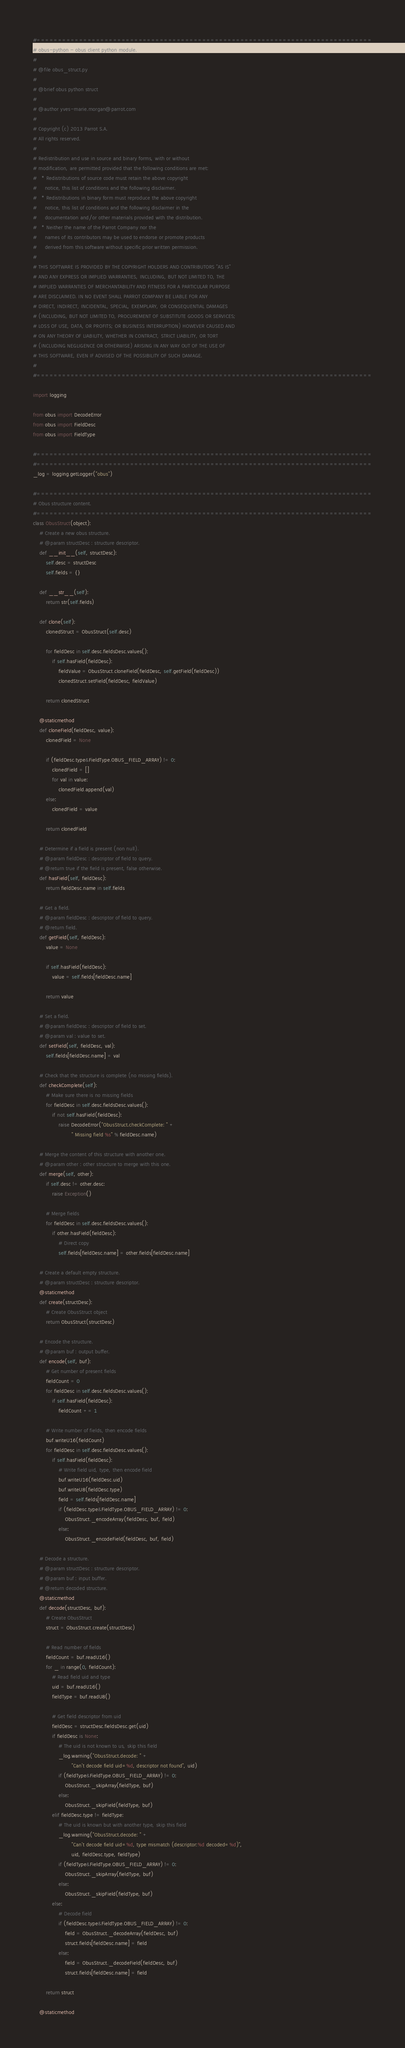Convert code to text. <code><loc_0><loc_0><loc_500><loc_500><_Python_>#===============================================================================
# obus-python - obus client python module.
#
# @file obus_struct.py
#
# @brief obus python struct
#
# @author yves-marie.morgan@parrot.com
#
# Copyright (c) 2013 Parrot S.A.
# All rights reserved.
#
# Redistribution and use in source and binary forms, with or without
# modification, are permitted provided that the following conditions are met:
#   * Redistributions of source code must retain the above copyright
#     notice, this list of conditions and the following disclaimer.
#   * Redistributions in binary form must reproduce the above copyright
#     notice, this list of conditions and the following disclaimer in the
#     documentation and/or other materials provided with the distribution.
#   * Neither the name of the Parrot Company nor the
#     names of its contributors may be used to endorse or promote products
#     derived from this software without specific prior written permission.
#
# THIS SOFTWARE IS PROVIDED BY THE COPYRIGHT HOLDERS AND CONTRIBUTORS "AS IS"
# AND ANY EXPRESS OR IMPLIED WARRANTIES, INCLUDING, BUT NOT LIMITED TO, THE
# IMPLIED WARRANTIES OF MERCHANTABILITY AND FITNESS FOR A PARTICULAR PURPOSE
# ARE DISCLAIMED. IN NO EVENT SHALL PARROT COMPANY BE LIABLE FOR ANY
# DIRECT, INDIRECT, INCIDENTAL, SPECIAL, EXEMPLARY, OR CONSEQUENTIAL DAMAGES
# (INCLUDING, BUT NOT LIMITED TO, PROCUREMENT OF SUBSTITUTE GOODS OR SERVICES;
# LOSS OF USE, DATA, OR PROFITS; OR BUSINESS INTERRUPTION) HOWEVER CAUSED AND
# ON ANY THEORY OF LIABILITY, WHETHER IN CONTRACT, STRICT LIABILITY, OR TORT
# (INCLUDING NEGLIGENCE OR OTHERWISE) ARISING IN ANY WAY OUT OF THE USE OF
# THIS SOFTWARE, EVEN IF ADVISED OF THE POSSIBILITY OF SUCH DAMAGE.
#
#===============================================================================

import logging

from obus import DecodeError
from obus import FieldDesc
from obus import FieldType

#===============================================================================
#===============================================================================
_log = logging.getLogger("obus")

#===============================================================================
# Obus structure content.
#===============================================================================
class ObusStruct(object):
	# Create a new obus structure.
	# @param structDesc : structure descriptor.
	def __init__(self, structDesc):
		self.desc = structDesc
		self.fields = {}

	def __str__(self):
		return str(self.fields)

	def clone(self):
		clonedStruct = ObusStruct(self.desc)

		for fieldDesc in self.desc.fieldsDesc.values():
			if self.hasField(fieldDesc):
				fieldValue = ObusStruct.cloneField(fieldDesc, self.getField(fieldDesc))
				clonedStruct.setField(fieldDesc, fieldValue)

		return clonedStruct

	@staticmethod
	def cloneField(fieldDesc, value):
		clonedField = None

		if (fieldDesc.type&FieldType.OBUS_FIELD_ARRAY) != 0:
			clonedField = []
			for val in value:
				clonedField.append(val)
		else:
			clonedField = value

		return clonedField

	# Determine if a field is present (non null).
	# @param fieldDesc : descriptor of field to query.
	# @return true if the field is present, false otherwise.
	def hasField(self, fieldDesc):
		return fieldDesc.name in self.fields

	# Get a field.
	# @param fieldDesc : descriptor of field to query.
	# @return field.
	def getField(self, fieldDesc):
		value = None

		if self.hasField(fieldDesc):
			value = self.fields[fieldDesc.name]

		return value

	# Set a field.
	# @param fieldDesc : descriptor of field to set.
	# @param val : value to set.
	def setField(self, fieldDesc, val):
		self.fields[fieldDesc.name] = val

	# Check that the structure is complete (no missing fields).
	def checkComplete(self):
		# Make sure there is no missing fields
		for fieldDesc in self.desc.fieldsDesc.values():
			if not self.hasField(fieldDesc):
				raise DecodeError("ObusStruct.checkComplete: " +
						" Missing field %s" % fieldDesc.name)

	# Merge the content of this structure with another one.
	# @param other : other structure to merge with this one.
	def merge(self, other):
		if self.desc != other.desc:
			raise Exception()

		# Merge fields
		for fieldDesc in self.desc.fieldsDesc.values():
			if other.hasField(fieldDesc):
				# Direct copy
				self.fields[fieldDesc.name] = other.fields[fieldDesc.name]

	# Create a default empty structure.
	# @param structDesc : structure descriptor.
	@staticmethod
	def create(structDesc):
		# Create ObusStruct object
		return ObusStruct(structDesc)

	# Encode the structure.
	# @param buf : output buffer.
	def encode(self, buf):
		# Get number of present fields
		fieldCount = 0
		for fieldDesc in self.desc.fieldsDesc.values():
			if self.hasField(fieldDesc):
				fieldCount += 1

		# Write number of fields, then encode fields
		buf.writeU16(fieldCount)
		for fieldDesc in self.desc.fieldsDesc.values():
			if self.hasField(fieldDesc):
				# Write field uid, type, then encode field
				buf.writeU16(fieldDesc.uid)
				buf.writeU8(fieldDesc.type)
				field = self.fields[fieldDesc.name]
				if (fieldDesc.type&FieldType.OBUS_FIELD_ARRAY) != 0:
					ObusStruct._encodeArray(fieldDesc, buf, field)
				else:
					ObusStruct._encodeField(fieldDesc, buf, field)

	# Decode a structure.
	# @param structDesc : structure descriptor.
	# @param buf : input buffer.
	# @return decoded structure.
	@staticmethod
	def decode(structDesc, buf):
		# Create ObusStruct
		struct = ObusStruct.create(structDesc)

		# Read number of fields
		fieldCount = buf.readU16()
		for _ in range(0, fieldCount):
			# Read field uid and type
			uid = buf.readU16()
			fieldType = buf.readU8()

			# Get field descriptor from uid
			fieldDesc = structDesc.fieldsDesc.get(uid)
			if fieldDesc is None:
				# The uid is not known to us, skip this field
				_log.warning("ObusStruct.decode: " +
						"Can't decode field uid=%d, descriptor not found", uid)
				if (fieldType&FieldType.OBUS_FIELD_ARRAY) != 0:
					ObusStruct._skipArray(fieldType, buf)
				else:
					ObusStruct._skipField(fieldType, buf)
			elif fieldDesc.type != fieldType:
				# The uid is known but with another type, skip this field
				_log.warning("ObusStruct.decode: " +
						"Can't decode field uid=%d, type mismatch (descriptor:%d decoded=%d)",
						uid, fieldDesc.type, fieldType)
				if (fieldType&FieldType.OBUS_FIELD_ARRAY) != 0:
					ObusStruct._skipArray(fieldType, buf)
				else:
					ObusStruct._skipField(fieldType, buf)
			else:
				# Decode field
				if (fieldDesc.type&FieldType.OBUS_FIELD_ARRAY) != 0:
					field = ObusStruct._decodeArray(fieldDesc, buf)
					struct.fields[fieldDesc.name] = field
				else:
					field = ObusStruct._decodeField(fieldDesc, buf)
					struct.fields[fieldDesc.name] = field

		return struct

	@staticmethod</code> 